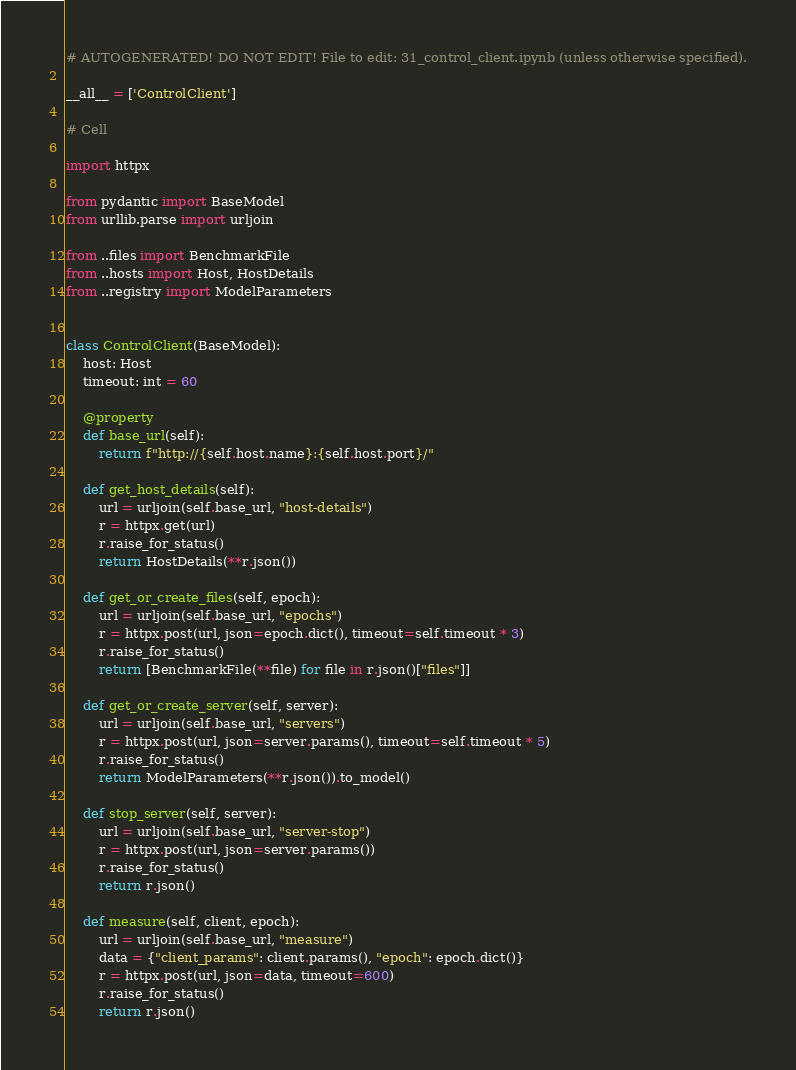Convert code to text. <code><loc_0><loc_0><loc_500><loc_500><_Python_># AUTOGENERATED! DO NOT EDIT! File to edit: 31_control_client.ipynb (unless otherwise specified).

__all__ = ['ControlClient']

# Cell

import httpx

from pydantic import BaseModel
from urllib.parse import urljoin

from ..files import BenchmarkFile
from ..hosts import Host, HostDetails
from ..registry import ModelParameters


class ControlClient(BaseModel):
    host: Host
    timeout: int = 60

    @property
    def base_url(self):
        return f"http://{self.host.name}:{self.host.port}/"

    def get_host_details(self):
        url = urljoin(self.base_url, "host-details")
        r = httpx.get(url)
        r.raise_for_status()
        return HostDetails(**r.json())

    def get_or_create_files(self, epoch):
        url = urljoin(self.base_url, "epochs")
        r = httpx.post(url, json=epoch.dict(), timeout=self.timeout * 3)
        r.raise_for_status()
        return [BenchmarkFile(**file) for file in r.json()["files"]]

    def get_or_create_server(self, server):
        url = urljoin(self.base_url, "servers")
        r = httpx.post(url, json=server.params(), timeout=self.timeout * 5)
        r.raise_for_status()
        return ModelParameters(**r.json()).to_model()

    def stop_server(self, server):
        url = urljoin(self.base_url, "server-stop")
        r = httpx.post(url, json=server.params())
        r.raise_for_status()
        return r.json()

    def measure(self, client, epoch):
        url = urljoin(self.base_url, "measure")
        data = {"client_params": client.params(), "epoch": epoch.dict()}
        r = httpx.post(url, json=data, timeout=600)
        r.raise_for_status()
        return r.json()</code> 